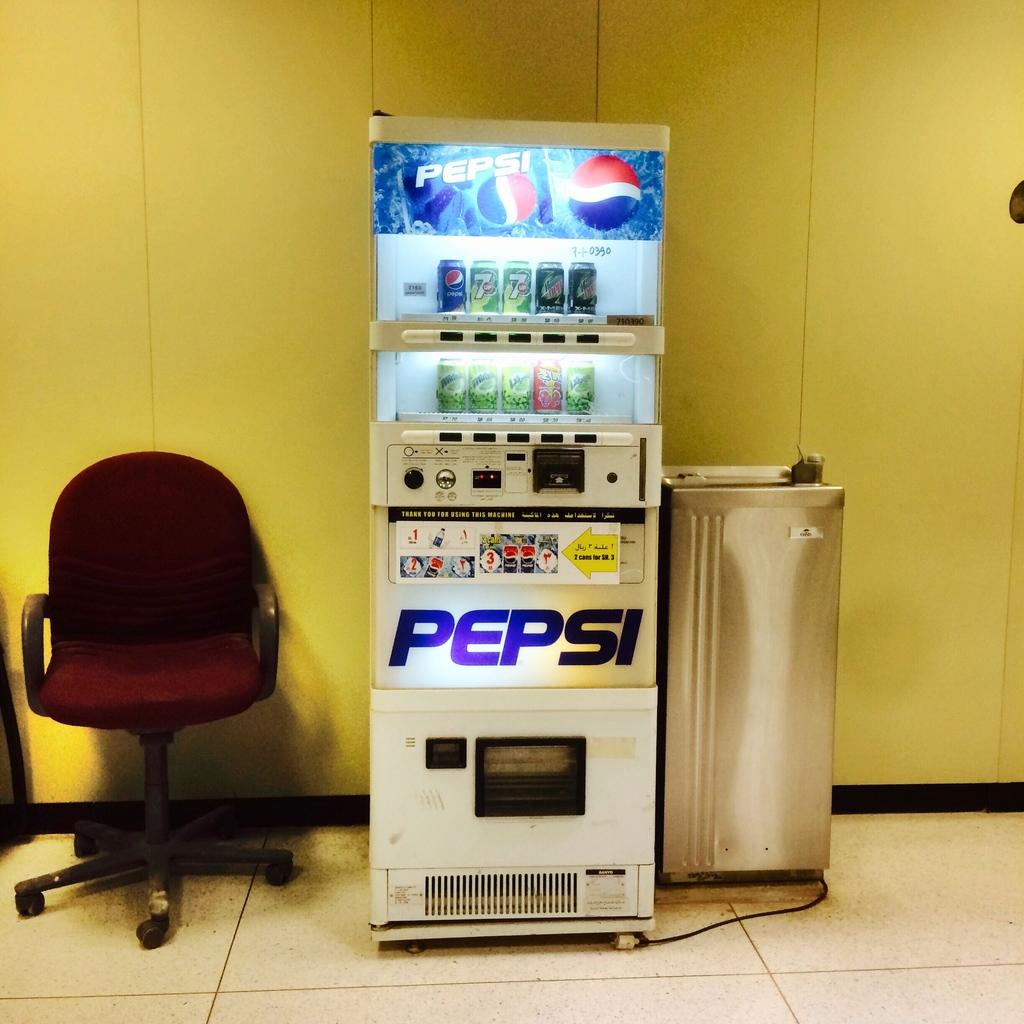What beverage company's products are sold from this vending machine?
Offer a terse response. Pepsi. 